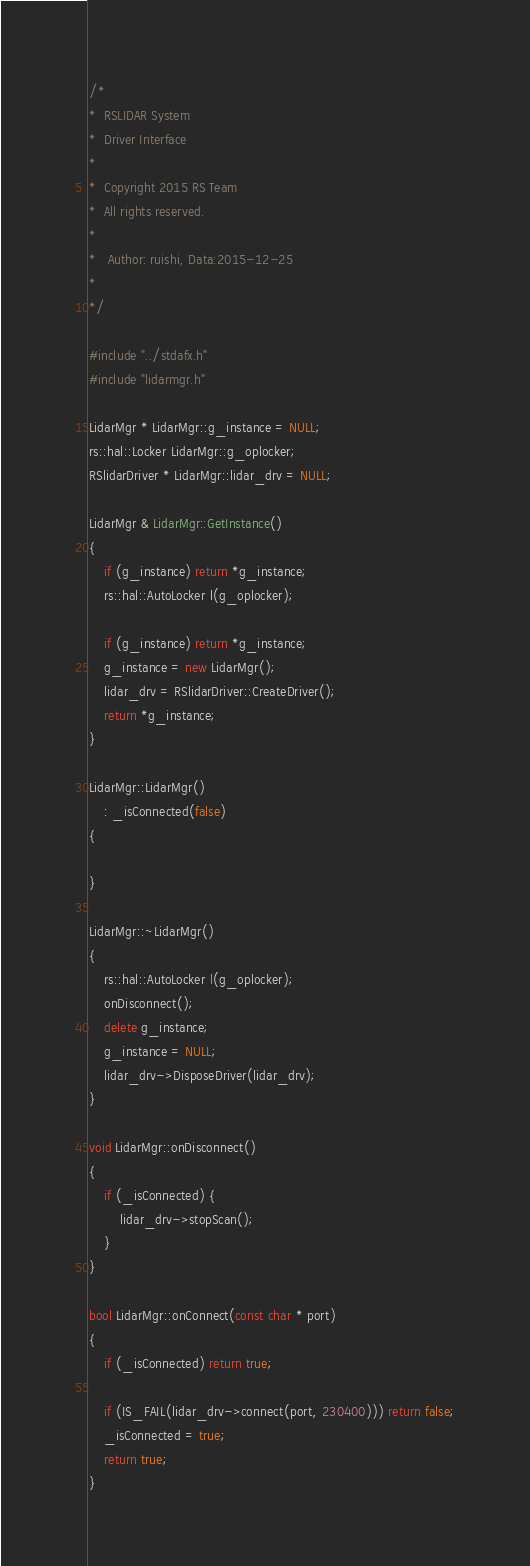<code> <loc_0><loc_0><loc_500><loc_500><_C++_>/*
*  RSLIDAR System
*  Driver Interface
*
*  Copyright 2015 RS Team
*  All rights reserved.
*
*	Author: ruishi, Data:2015-12-25
*
*/

#include "../stdafx.h"
#include "lidarmgr.h"

LidarMgr * LidarMgr::g_instance = NULL;
rs::hal::Locker LidarMgr::g_oplocker;
RSlidarDriver * LidarMgr::lidar_drv = NULL;

LidarMgr & LidarMgr::GetInstance()
{
    if (g_instance) return *g_instance;
    rs::hal::AutoLocker l(g_oplocker);

    if (g_instance) return *g_instance;
    g_instance = new LidarMgr();
	lidar_drv = RSlidarDriver::CreateDriver();
    return *g_instance;
}

LidarMgr::LidarMgr()
    : _isConnected(false)
{

}

LidarMgr::~LidarMgr()
{
    rs::hal::AutoLocker l(g_oplocker);
    onDisconnect();
	delete g_instance;
	g_instance = NULL;
	lidar_drv->DisposeDriver(lidar_drv);
}

void LidarMgr::onDisconnect()
{
    if (_isConnected) {
        lidar_drv->stopScan();
    }
}

bool LidarMgr::onConnect(const char * port)
{
    if (_isConnected) return true;

    if (IS_FAIL(lidar_drv->connect(port, 230400))) return false;
    _isConnected = true;
    return true;
}</code> 